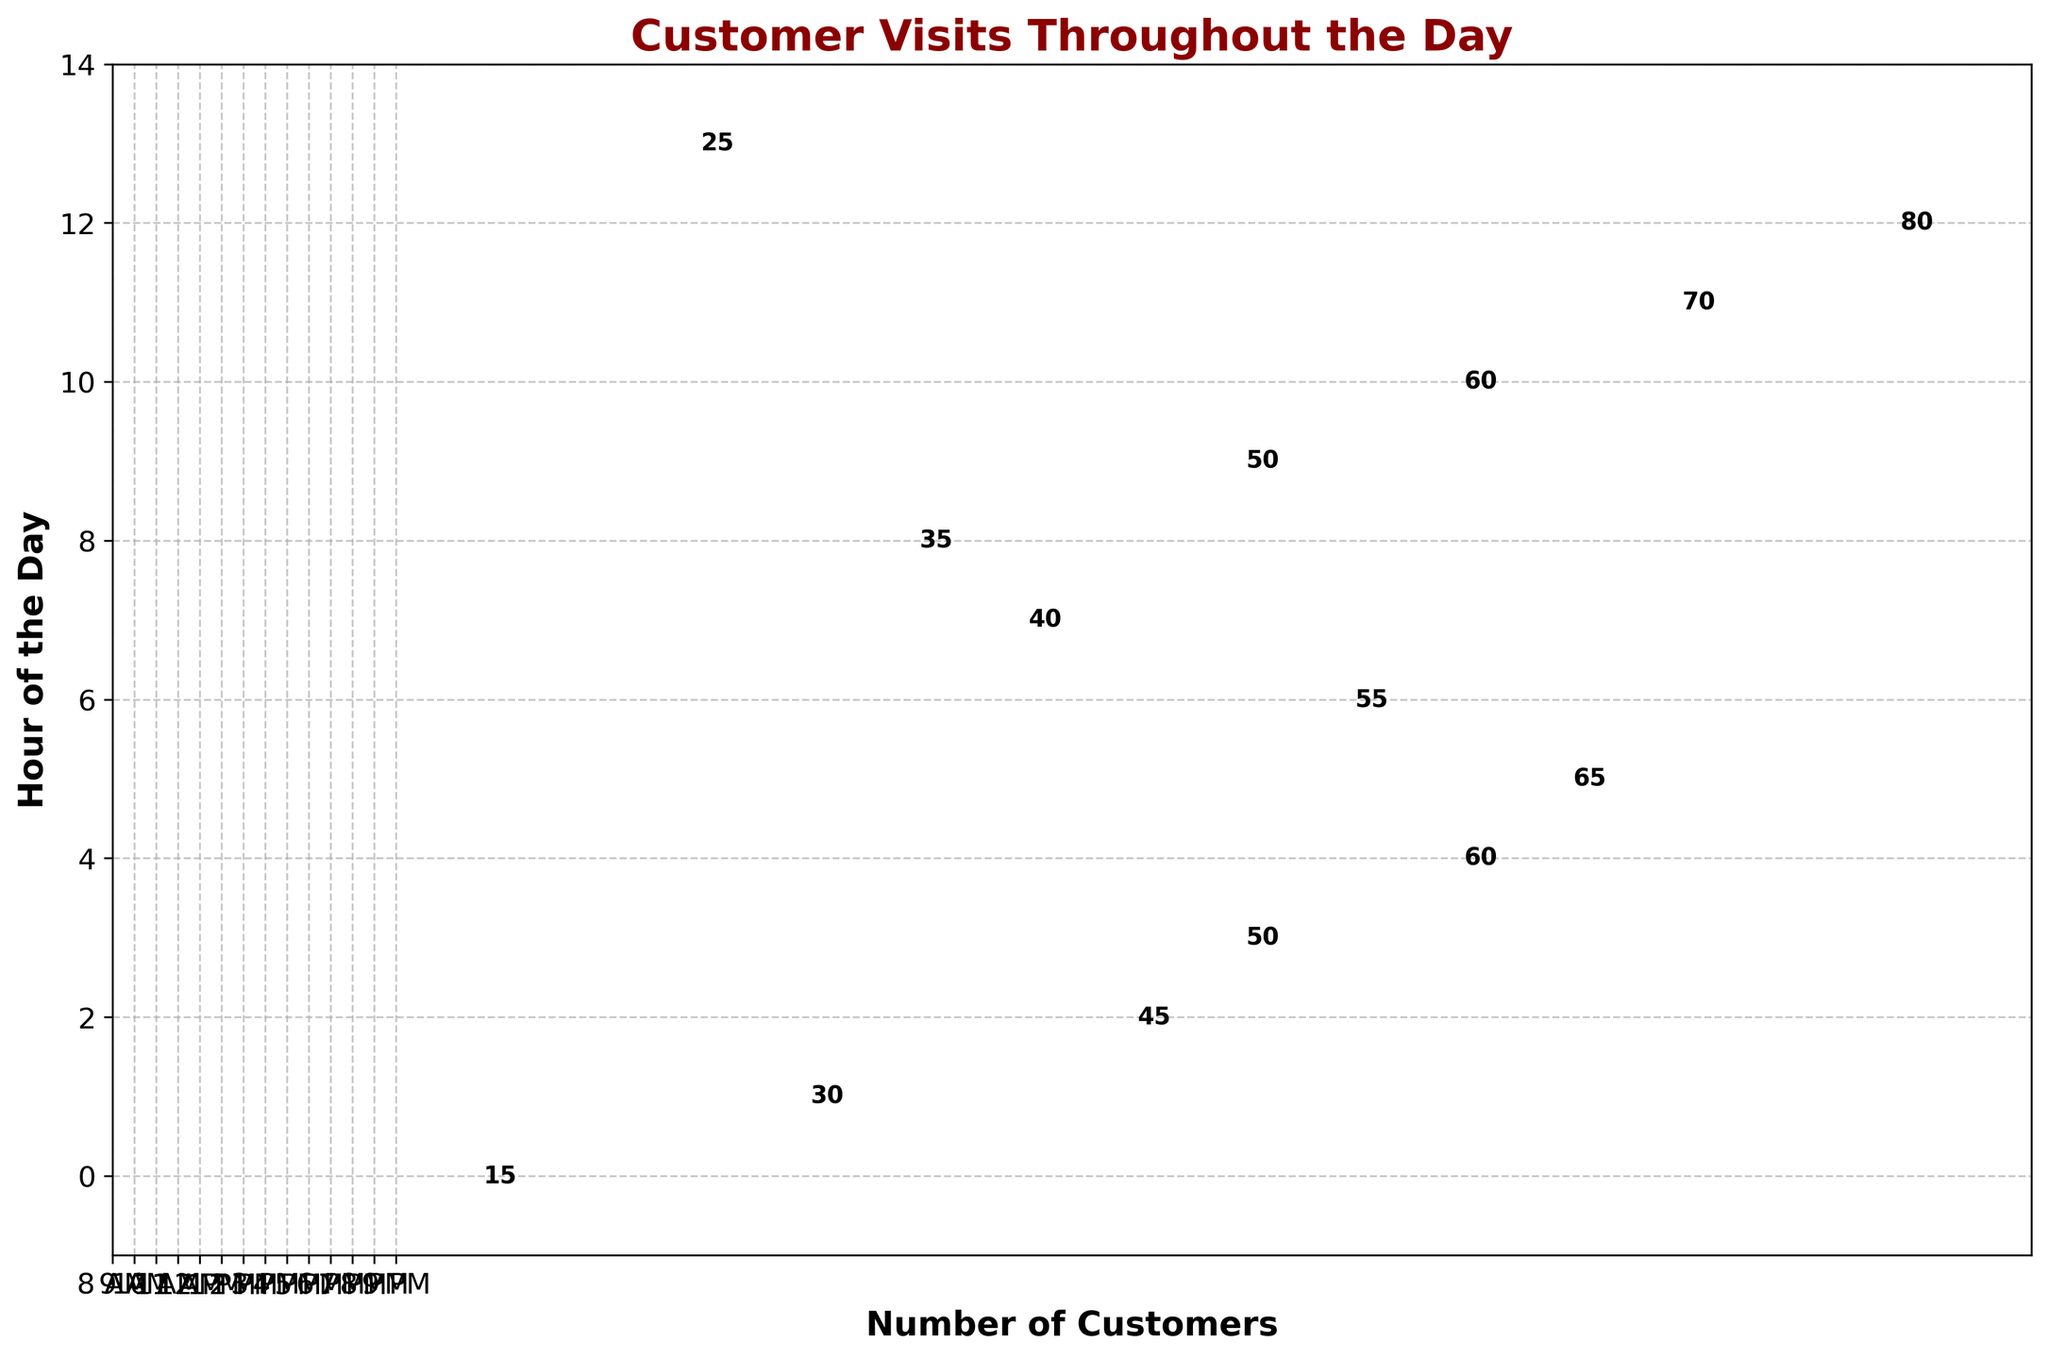What is the title of the plot? The title of the plot is displayed at the top, it is "Customer Visits Throughout the Day."
Answer: Customer Visits Throughout the Day What is the highest number of customers at any hour of the day? The figure shows stems representing the number of customers by hour. The longest stem, representing the highest number, is for 8 PM, with 80 customers.
Answer: 80 At which hour do the fewest customers visit the store? By observing the shortest stem in the plot, the hour with the fewest customers appears to be 8 AM, with 15 customers.
Answer: 8 AM What is the total number of customer visits from 8 AM to 9 PM? To find the total number of customer visits, sum all the numbers for each hour: 15 + 30 + 45 + 50 + 60 + 65 + 55 + 40 + 35 + 50 + 60 + 70 + 80 + 25 = 680.
Answer: 680 Which hour has more customers: 1 PM or 3 PM? By comparing the stems for 1 PM and 3 PM, 1 PM has 65 customers, and 3 PM has 40 customers. 1 PM has more customers than 3 PM.
Answer: 1 PM Between which two consecutive hours is the increase in the number of customers the highest? Looking at the differences between consecutive hours' customer numbers, the increase from 7 PM to 8 PM is the highest: 80 - 70 = 10 customers.
Answer: 7 PM to 8 PM What is the average number of customers visiting per hour? Sum the number of customers for all hours and divide by the total number of hours: 680 total customers / 14 hours = 48.6 customers per hour, approximately 49.
Answer: 49 Is there any hour when exactly 50 customers visited the store? By inspecting the stems, it can be seen that at both 11 AM and 5 PM, exactly 50 customers visited the store.
Answer: Yes, 11 AM and 5 PM How many hours have customer numbers greater than 50? By counting the stems, the hours with more than 50 customers are 12 PM, 1 PM, 2 PM, 6 PM, 7 PM, and 8 PM, which totals to 6 hours.
Answer: 6 What is the difference in the number of customers between the busiest and the least busy hour? The busiest hour (8 PM) has 80 customers, and the least busy hour (8 AM) has 15 customers. The difference is 80 - 15 = 65 customers.
Answer: 65 